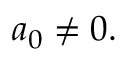<formula> <loc_0><loc_0><loc_500><loc_500>a _ { 0 } \neq 0 .</formula> 